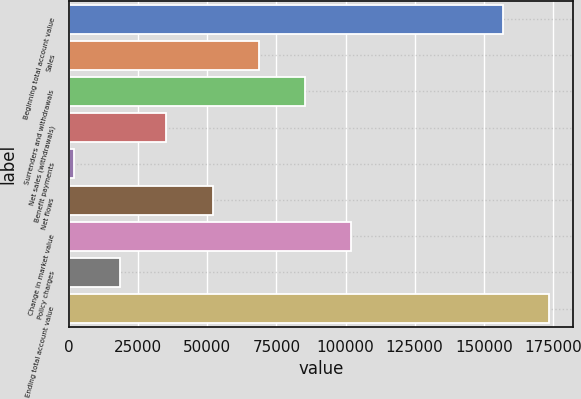Convert chart. <chart><loc_0><loc_0><loc_500><loc_500><bar_chart><fcel>Beginning total account value<fcel>Sales<fcel>Surrenders and withdrawals<fcel>Net sales (withdrawals)<fcel>Benefit payments<fcel>Net flows<fcel>Change in market value<fcel>Policy charges<fcel>Ending total account value<nl><fcel>156783<fcel>68574.2<fcel>85249.5<fcel>35223.6<fcel>1873<fcel>51898.9<fcel>101925<fcel>18548.3<fcel>173458<nl></chart> 